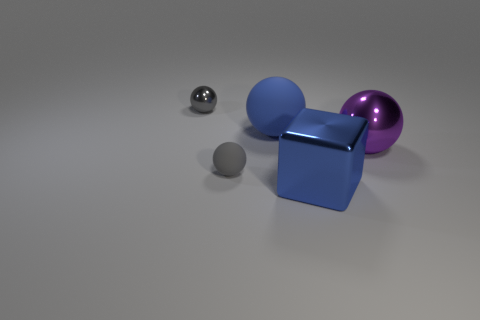The thing that is both behind the purple shiny object and to the right of the tiny gray rubber ball is made of what material?
Make the answer very short. Rubber. The blue shiny thing that is the same size as the purple thing is what shape?
Make the answer very short. Cube. There is a tiny thing on the left side of the gray sphere in front of the tiny gray object that is behind the tiny gray rubber object; what is its color?
Your answer should be compact. Gray. What number of objects are either small shiny things on the left side of the large rubber sphere or yellow rubber things?
Your response must be concise. 1. What material is the cube that is the same size as the purple metallic object?
Keep it short and to the point. Metal. What is the material of the small sphere that is behind the big blue thing behind the matte thing that is in front of the purple ball?
Keep it short and to the point. Metal. What is the color of the tiny rubber thing?
Your answer should be very brief. Gray. What number of tiny objects are matte balls or blue shiny objects?
Keep it short and to the point. 1. There is a sphere that is the same color as the cube; what is its material?
Provide a succinct answer. Rubber. Does the blue object that is on the right side of the big matte object have the same material as the big ball to the left of the blue metallic thing?
Give a very brief answer. No. 